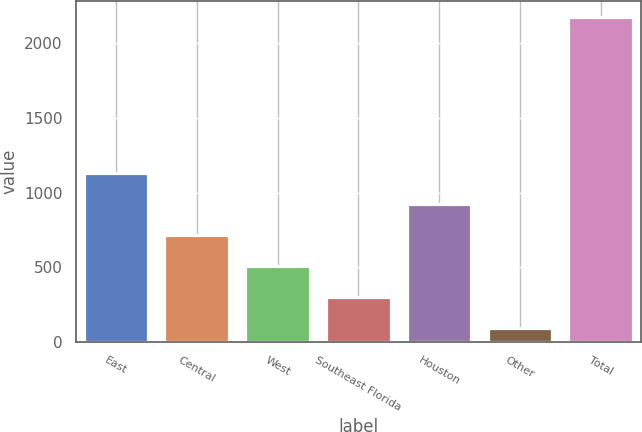Convert chart to OTSL. <chart><loc_0><loc_0><loc_500><loc_500><bar_chart><fcel>East<fcel>Central<fcel>West<fcel>Southeast Florida<fcel>Houston<fcel>Other<fcel>Total<nl><fcel>1133<fcel>717.8<fcel>510.2<fcel>302.6<fcel>925.4<fcel>95<fcel>2171<nl></chart> 